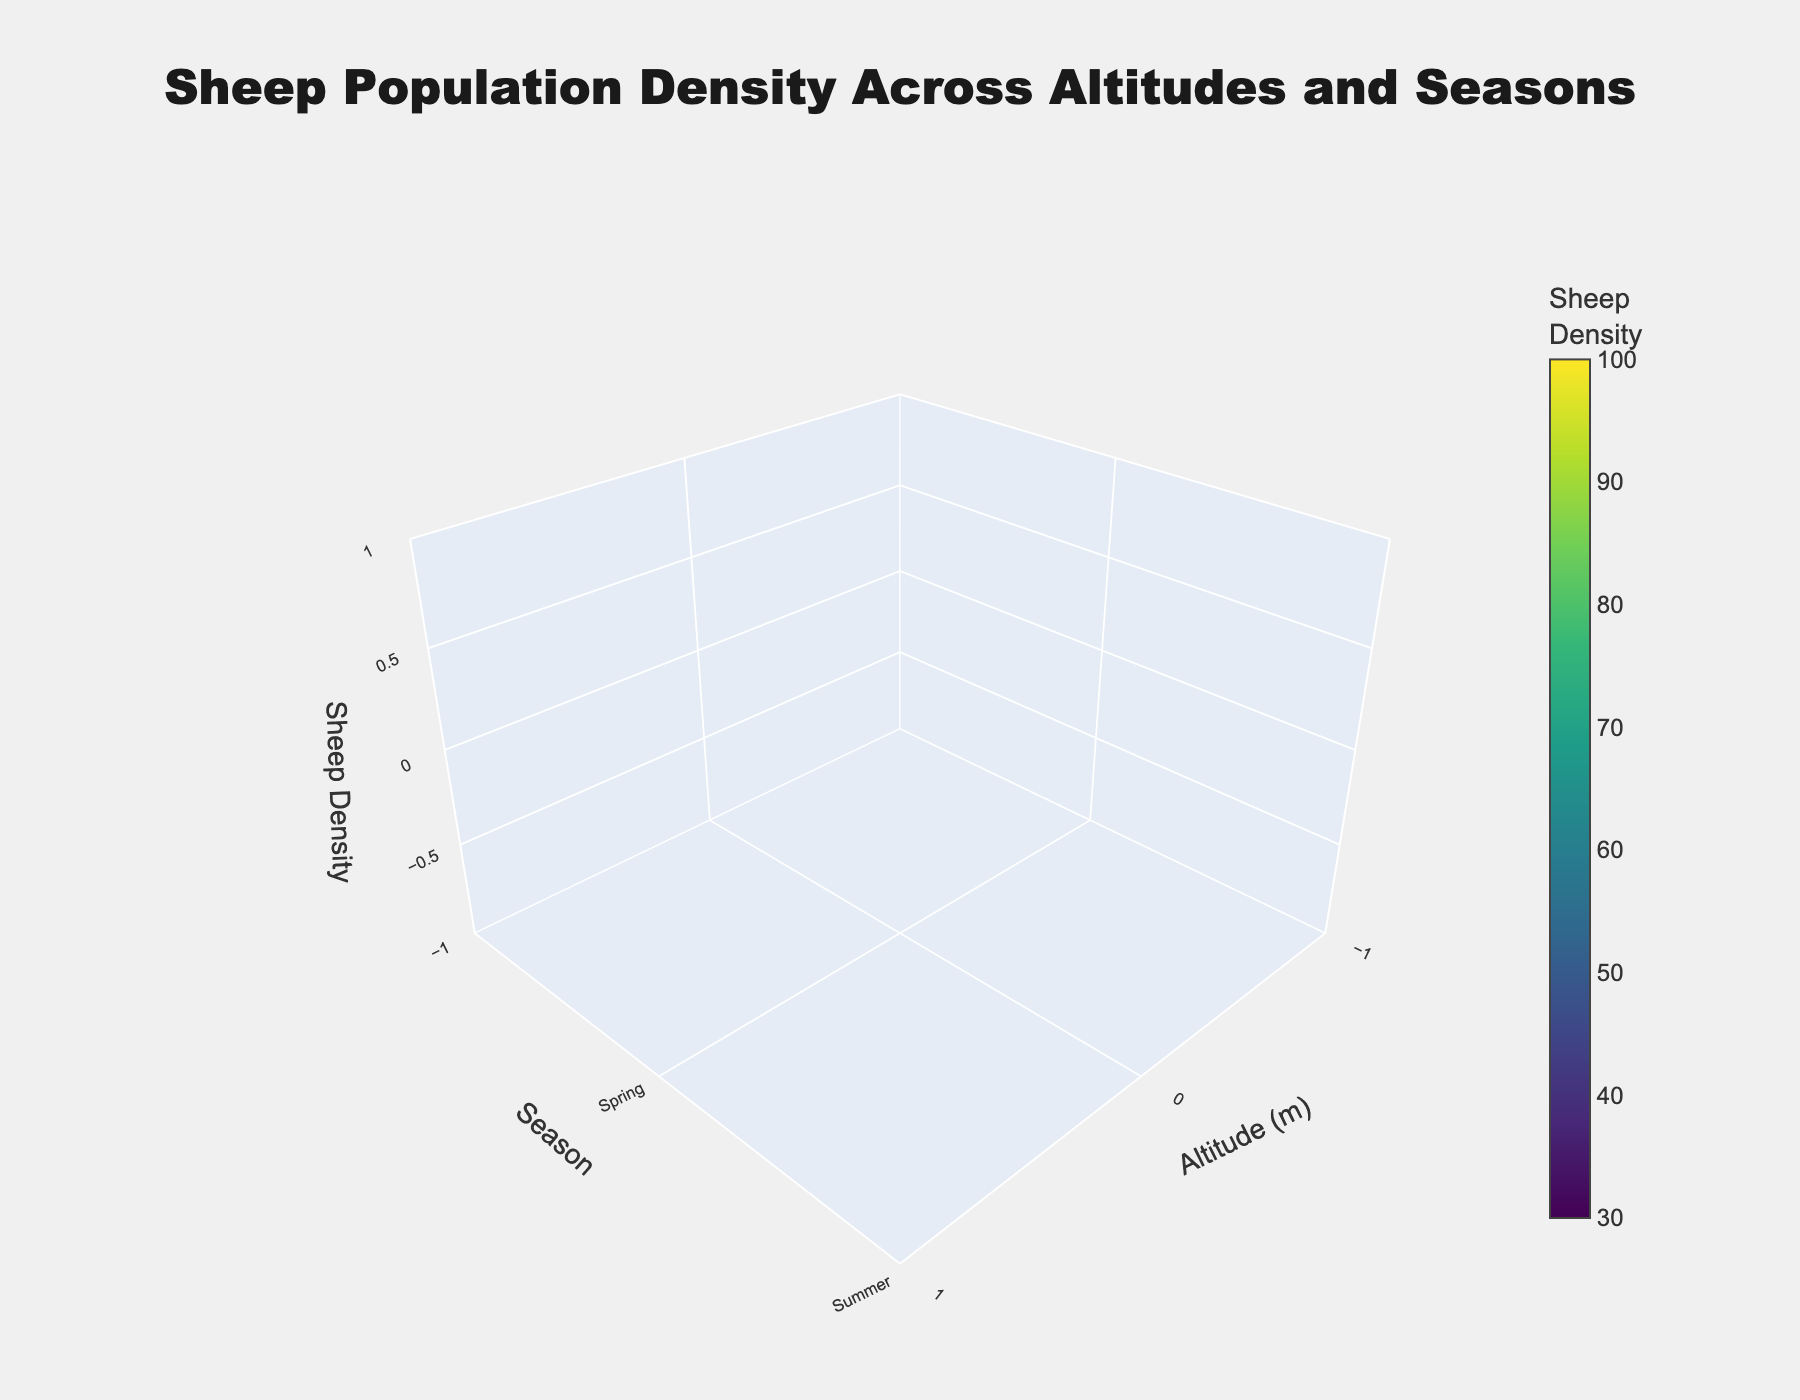what is the title of the figure? The title of the figure is found at the top of the 3D volume plot. It reads "Sheep Population Density Across Altitudes and Seasons," indicating the scope of the data visualized.
Answer: Sheep Population Density Across Altitudes and Seasons what are the three axes labeled in the plot? The axes are labeled to reflect the variables being plotted. The x-axis is labeled "Altitude (m)," the y-axis is labeled "Season," and the z-axis is labeled "Sheep Density." These labels help understand what each dimension of the 3D volume plot represents.
Answer: Altitude (m), Season, Sheep Density which season appears to have the lowest average sheep density across all altitudes? To determine the season with the lowest average sheep density, we examine sheep densities for each altitude within each season and calculate the mean. Winter has lower densities overall, especially at altitudes of 1500m and 2000m.
Answer: Winter at which altitude and season are sheep densities the highest? The highest value on the z-axis is analyzed across x (Altitude) and y (Season). Observing the plot, the highest sheep density occurs in Summer at 1500 meters altitude.
Answer: 1500 meters in Summer is there a consistent trend in sheep density change with altitude in any season? Examining the z-axis values for each fixed season while moving along the x-axis (altitude) can identify trends. Sleep density generally decreases from 1000m to 2000m in Winter.
Answer: Yes, in Winter how does sheep density in the Spring at 500m compare to Winter at 0m? Compare the z values corresponding to these specific x and y coordinates: 500m in Spring has a density around 60, while at 0m in Winter, it's around 50.
Answer: Higher in Spring at 500m what's the total sheep density for all altitudes in Summer? Summing up the sheep densities for all given altitudes in Summer: 30 (0m) + 75 (500m) + 95 (1000m) + 100 (1500m) + 90 (2000m) = 390 sheep density units.
Answer: 390 which altitude experiences the highest variation in sheep density across seasons? To find this, calculate the range (difference between max and min) of sheep densities across the seasons for each altitude. The highest variation occurs at 2000m, varying from 30 (Winter) to 90 (Summer).
Answer: 2000 meters is the sheep density generally higher or lower in Spring compared to Autumn? Compare average densities for Spring and Autumn across altitudes. Most altitudes show higher densities in Spring, except for 1000m where it’s slightly lower.
Answer: Generally higher in Spring what color scale is used to show sheep density? The 3D volume plot uses the 'Viridis' color scale, which smoothly transitions colors based on the sheep density values represented. This color gradient helps visually differentiate the density values.
Answer: Viridis 